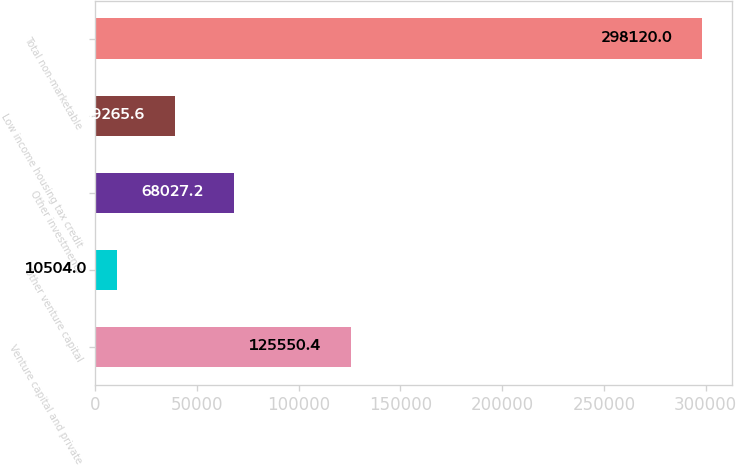Convert chart to OTSL. <chart><loc_0><loc_0><loc_500><loc_500><bar_chart><fcel>Venture capital and private<fcel>Other venture capital<fcel>Other investments<fcel>Low income housing tax credit<fcel>Total non-marketable<nl><fcel>125550<fcel>10504<fcel>68027.2<fcel>39265.6<fcel>298120<nl></chart> 